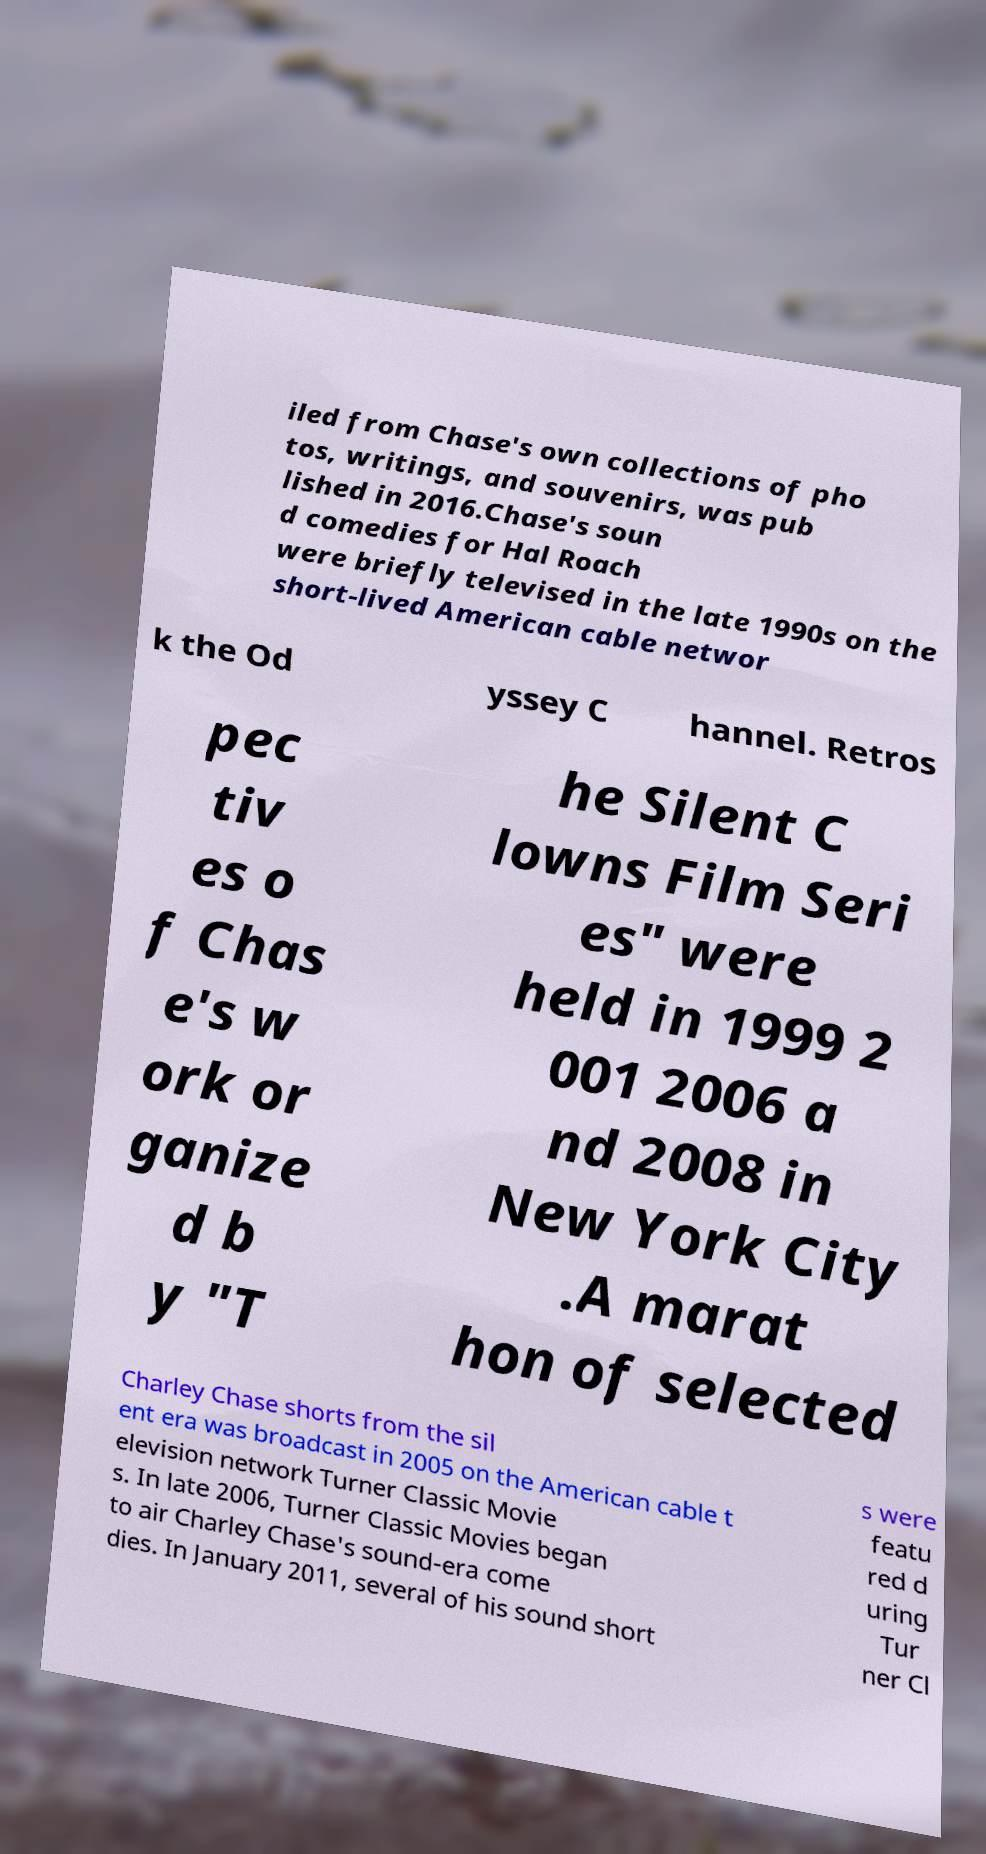Could you extract and type out the text from this image? iled from Chase's own collections of pho tos, writings, and souvenirs, was pub lished in 2016.Chase's soun d comedies for Hal Roach were briefly televised in the late 1990s on the short-lived American cable networ k the Od yssey C hannel. Retros pec tiv es o f Chas e's w ork or ganize d b y "T he Silent C lowns Film Seri es" were held in 1999 2 001 2006 a nd 2008 in New York City .A marat hon of selected Charley Chase shorts from the sil ent era was broadcast in 2005 on the American cable t elevision network Turner Classic Movie s. In late 2006, Turner Classic Movies began to air Charley Chase's sound-era come dies. In January 2011, several of his sound short s were featu red d uring Tur ner Cl 